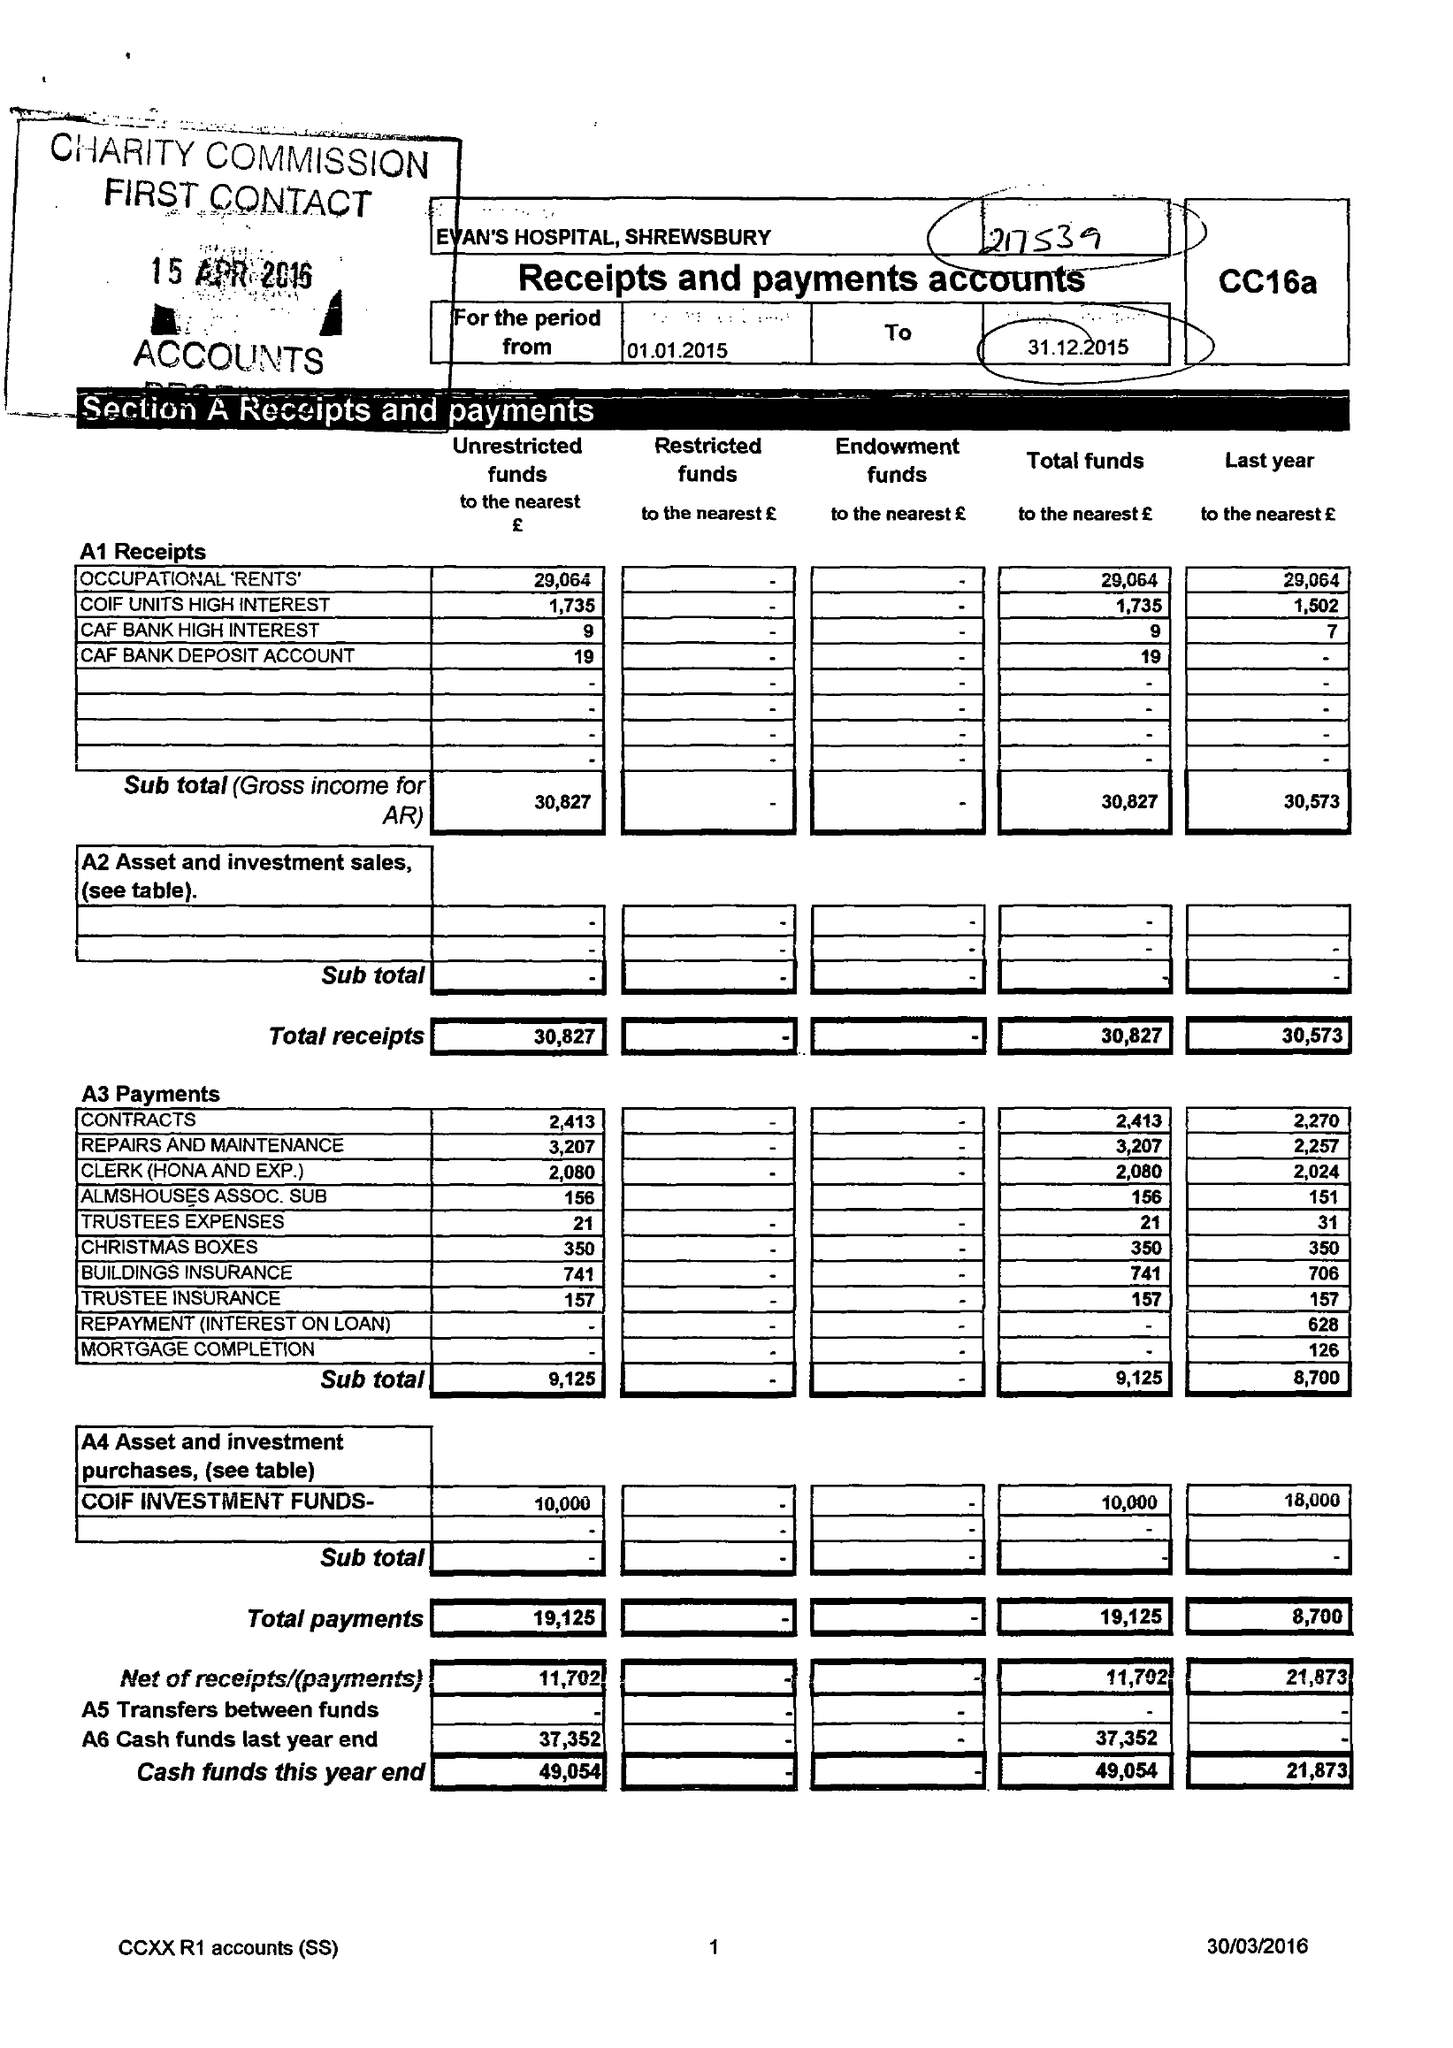What is the value for the address__post_town?
Answer the question using a single word or phrase. SHREWSBURY 